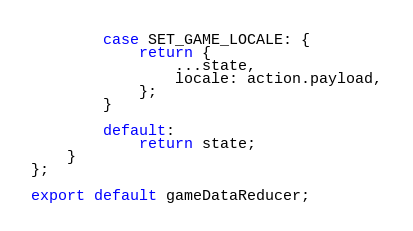<code> <loc_0><loc_0><loc_500><loc_500><_JavaScript_>
        case SET_GAME_LOCALE: {
            return {
                ...state,
                locale: action.payload,
            };
        }

        default:
            return state;
    }
};

export default gameDataReducer;
</code> 